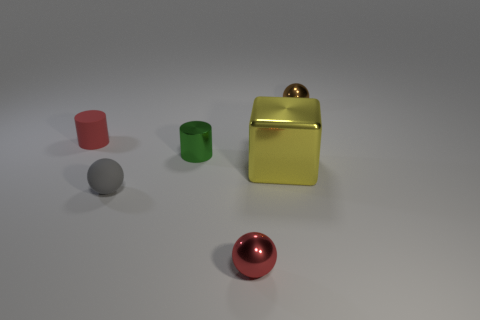Subtract all tiny brown balls. How many balls are left? 2 Add 2 small cyan rubber objects. How many objects exist? 8 Subtract 1 spheres. How many spheres are left? 2 Subtract all red balls. How many balls are left? 2 Subtract all cylinders. How many objects are left? 4 Subtract all purple cubes. How many green cylinders are left? 1 Subtract all yellow rubber cubes. Subtract all red spheres. How many objects are left? 5 Add 4 red rubber cylinders. How many red rubber cylinders are left? 5 Add 3 small red matte cylinders. How many small red matte cylinders exist? 4 Subtract 0 yellow cylinders. How many objects are left? 6 